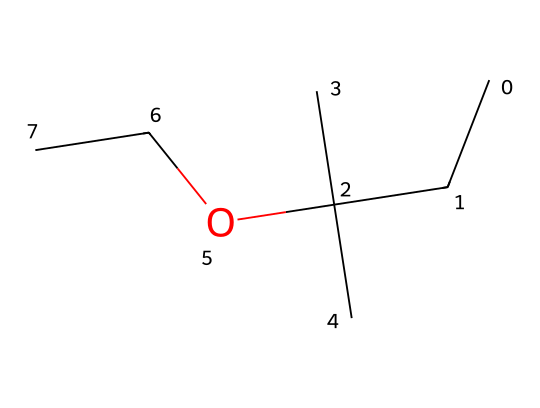What is the molecular formula of ethyl tert-butyl ether? To determine the molecular formula, analyze the SMILES representation, where 'C' indicates carbon and 'O' indicates oxygen. Counting the carbon atoms gives 8 and the oxygen gives 1. So, the molecular formula is C8H18O.
Answer: C8H18O How many carbon atoms are in ethyl tert-butyl ether? In the SMILES representation, count the 'C' letters. There are 8 carbon atoms in total.
Answer: 8 What type of functional group is present in ethyl tert-butyl ether? The presence of the oxygen atom connected to two carbon groups indicates that this compound is an ether.
Answer: ether What is the IUPAC name of this ether compound? The structure has a tert-butyl group and an ethyl group, thus the IUPAC name is ethyl tert-butyl ether.
Answer: ethyl tert-butyl ether How many hydrogen atoms are bonded to the tert-butyl group in ethyl tert-butyl ether? The tert-butyl group (C(C)(C)C) has 9 hydrogen atoms connected to it as each carbon can bond with three hydrogen atoms, making an addition 3 to the carbon backbone and the branching.
Answer: 9 What type of bond connects the carbon and oxygen atoms in ethyl tert-butyl ether? The carbon and oxygen are connected by a single bond, which is characteristic of ethers.
Answer: single bond 